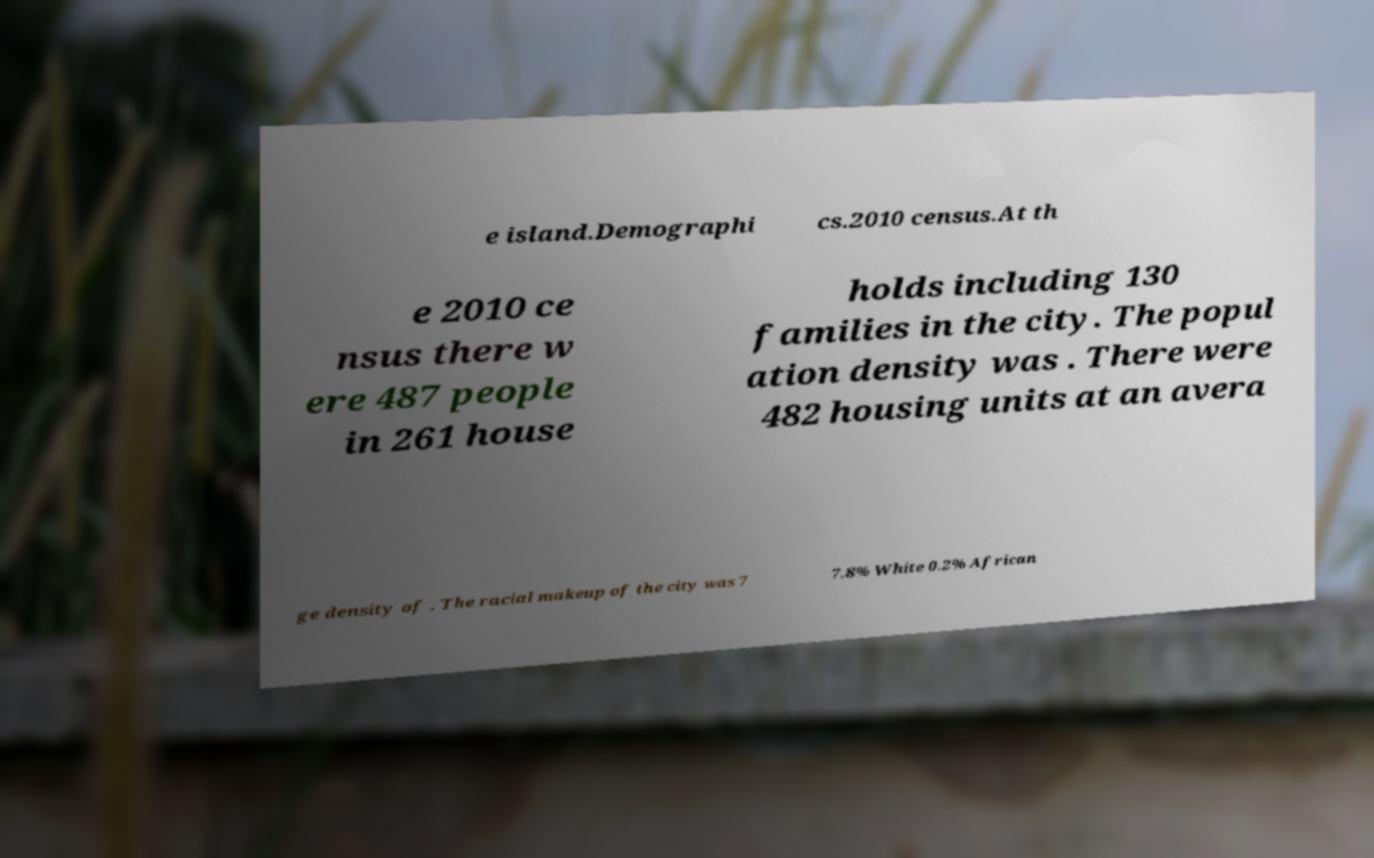Could you extract and type out the text from this image? e island.Demographi cs.2010 census.At th e 2010 ce nsus there w ere 487 people in 261 house holds including 130 families in the city. The popul ation density was . There were 482 housing units at an avera ge density of . The racial makeup of the city was 7 7.8% White 0.2% African 